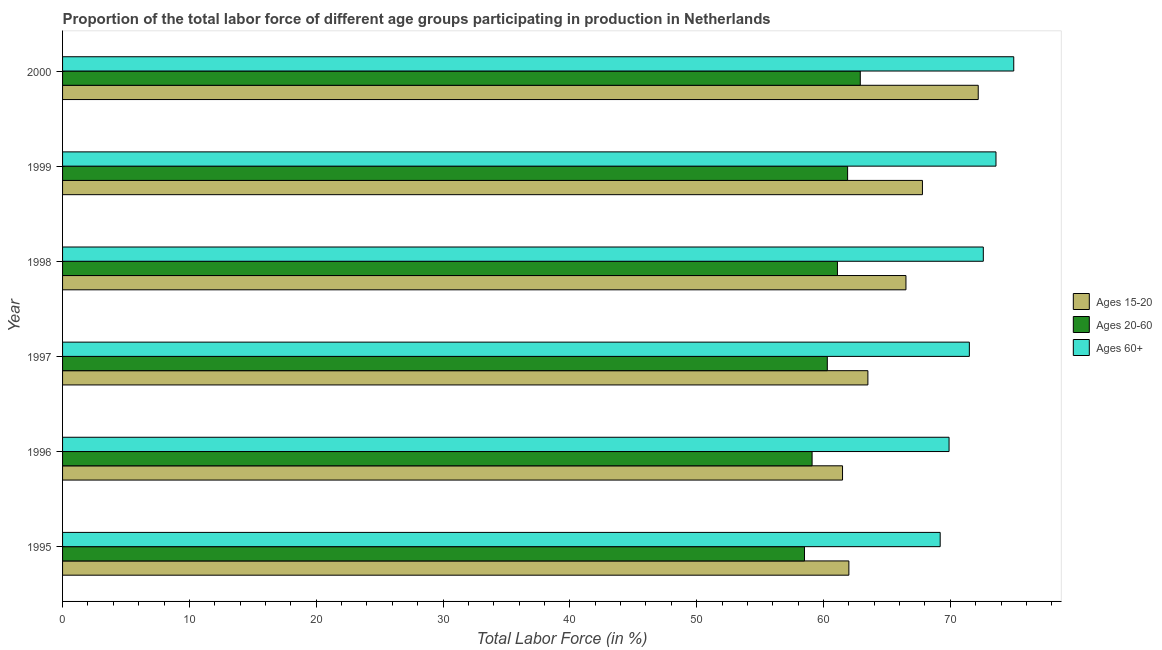How many groups of bars are there?
Make the answer very short. 6. Are the number of bars per tick equal to the number of legend labels?
Offer a very short reply. Yes. How many bars are there on the 6th tick from the bottom?
Ensure brevity in your answer.  3. What is the label of the 4th group of bars from the top?
Give a very brief answer. 1997. In how many cases, is the number of bars for a given year not equal to the number of legend labels?
Provide a succinct answer. 0. What is the percentage of labor force within the age group 20-60 in 1998?
Offer a very short reply. 61.1. Across all years, what is the maximum percentage of labor force within the age group 20-60?
Provide a succinct answer. 62.9. Across all years, what is the minimum percentage of labor force within the age group 15-20?
Ensure brevity in your answer.  61.5. In which year was the percentage of labor force above age 60 maximum?
Offer a terse response. 2000. What is the total percentage of labor force within the age group 15-20 in the graph?
Offer a very short reply. 393.5. What is the difference between the percentage of labor force within the age group 20-60 in 1997 and the percentage of labor force above age 60 in 1996?
Your answer should be very brief. -9.6. What is the average percentage of labor force within the age group 15-20 per year?
Ensure brevity in your answer.  65.58. In how many years, is the percentage of labor force within the age group 15-20 greater than 72 %?
Your answer should be very brief. 1. What is the ratio of the percentage of labor force above age 60 in 1999 to that in 2000?
Make the answer very short. 0.98. Is the percentage of labor force within the age group 20-60 in 1995 less than that in 1999?
Your answer should be compact. Yes. What is the difference between the highest and the lowest percentage of labor force within the age group 20-60?
Your answer should be very brief. 4.4. Is the sum of the percentage of labor force within the age group 20-60 in 1997 and 1999 greater than the maximum percentage of labor force within the age group 15-20 across all years?
Keep it short and to the point. Yes. What does the 3rd bar from the top in 2000 represents?
Offer a very short reply. Ages 15-20. What does the 2nd bar from the bottom in 2000 represents?
Your response must be concise. Ages 20-60. Is it the case that in every year, the sum of the percentage of labor force within the age group 15-20 and percentage of labor force within the age group 20-60 is greater than the percentage of labor force above age 60?
Offer a terse response. Yes. How many bars are there?
Make the answer very short. 18. How many legend labels are there?
Offer a terse response. 3. What is the title of the graph?
Provide a short and direct response. Proportion of the total labor force of different age groups participating in production in Netherlands. Does "Coal" appear as one of the legend labels in the graph?
Keep it short and to the point. No. What is the Total Labor Force (in %) of Ages 20-60 in 1995?
Ensure brevity in your answer.  58.5. What is the Total Labor Force (in %) of Ages 60+ in 1995?
Give a very brief answer. 69.2. What is the Total Labor Force (in %) in Ages 15-20 in 1996?
Offer a very short reply. 61.5. What is the Total Labor Force (in %) in Ages 20-60 in 1996?
Keep it short and to the point. 59.1. What is the Total Labor Force (in %) of Ages 60+ in 1996?
Your answer should be very brief. 69.9. What is the Total Labor Force (in %) of Ages 15-20 in 1997?
Offer a terse response. 63.5. What is the Total Labor Force (in %) in Ages 20-60 in 1997?
Offer a terse response. 60.3. What is the Total Labor Force (in %) of Ages 60+ in 1997?
Offer a very short reply. 71.5. What is the Total Labor Force (in %) of Ages 15-20 in 1998?
Ensure brevity in your answer.  66.5. What is the Total Labor Force (in %) of Ages 20-60 in 1998?
Give a very brief answer. 61.1. What is the Total Labor Force (in %) of Ages 60+ in 1998?
Ensure brevity in your answer.  72.6. What is the Total Labor Force (in %) of Ages 15-20 in 1999?
Offer a terse response. 67.8. What is the Total Labor Force (in %) of Ages 20-60 in 1999?
Keep it short and to the point. 61.9. What is the Total Labor Force (in %) of Ages 60+ in 1999?
Your answer should be compact. 73.6. What is the Total Labor Force (in %) in Ages 15-20 in 2000?
Provide a succinct answer. 72.2. What is the Total Labor Force (in %) of Ages 20-60 in 2000?
Give a very brief answer. 62.9. What is the Total Labor Force (in %) of Ages 60+ in 2000?
Provide a short and direct response. 75. Across all years, what is the maximum Total Labor Force (in %) of Ages 15-20?
Your answer should be very brief. 72.2. Across all years, what is the maximum Total Labor Force (in %) in Ages 20-60?
Provide a succinct answer. 62.9. Across all years, what is the maximum Total Labor Force (in %) of Ages 60+?
Provide a short and direct response. 75. Across all years, what is the minimum Total Labor Force (in %) in Ages 15-20?
Your answer should be very brief. 61.5. Across all years, what is the minimum Total Labor Force (in %) of Ages 20-60?
Your response must be concise. 58.5. Across all years, what is the minimum Total Labor Force (in %) in Ages 60+?
Keep it short and to the point. 69.2. What is the total Total Labor Force (in %) of Ages 15-20 in the graph?
Your answer should be very brief. 393.5. What is the total Total Labor Force (in %) of Ages 20-60 in the graph?
Provide a short and direct response. 363.8. What is the total Total Labor Force (in %) in Ages 60+ in the graph?
Your answer should be very brief. 431.8. What is the difference between the Total Labor Force (in %) in Ages 20-60 in 1995 and that in 1996?
Provide a short and direct response. -0.6. What is the difference between the Total Labor Force (in %) of Ages 15-20 in 1995 and that in 1997?
Provide a short and direct response. -1.5. What is the difference between the Total Labor Force (in %) in Ages 20-60 in 1995 and that in 1997?
Your response must be concise. -1.8. What is the difference between the Total Labor Force (in %) of Ages 20-60 in 1995 and that in 1998?
Keep it short and to the point. -2.6. What is the difference between the Total Labor Force (in %) in Ages 15-20 in 1995 and that in 1999?
Your response must be concise. -5.8. What is the difference between the Total Labor Force (in %) in Ages 20-60 in 1995 and that in 1999?
Keep it short and to the point. -3.4. What is the difference between the Total Labor Force (in %) in Ages 60+ in 1995 and that in 1999?
Provide a succinct answer. -4.4. What is the difference between the Total Labor Force (in %) of Ages 60+ in 1996 and that in 1997?
Keep it short and to the point. -1.6. What is the difference between the Total Labor Force (in %) of Ages 20-60 in 1996 and that in 1998?
Offer a terse response. -2. What is the difference between the Total Labor Force (in %) in Ages 15-20 in 1996 and that in 1999?
Your answer should be compact. -6.3. What is the difference between the Total Labor Force (in %) in Ages 20-60 in 1996 and that in 1999?
Your answer should be very brief. -2.8. What is the difference between the Total Labor Force (in %) of Ages 15-20 in 1996 and that in 2000?
Provide a short and direct response. -10.7. What is the difference between the Total Labor Force (in %) in Ages 15-20 in 1997 and that in 1999?
Ensure brevity in your answer.  -4.3. What is the difference between the Total Labor Force (in %) in Ages 15-20 in 1998 and that in 1999?
Give a very brief answer. -1.3. What is the difference between the Total Labor Force (in %) of Ages 20-60 in 1998 and that in 1999?
Keep it short and to the point. -0.8. What is the difference between the Total Labor Force (in %) in Ages 20-60 in 1998 and that in 2000?
Make the answer very short. -1.8. What is the difference between the Total Labor Force (in %) of Ages 60+ in 1998 and that in 2000?
Your answer should be compact. -2.4. What is the difference between the Total Labor Force (in %) of Ages 20-60 in 1995 and the Total Labor Force (in %) of Ages 60+ in 1996?
Offer a very short reply. -11.4. What is the difference between the Total Labor Force (in %) in Ages 15-20 in 1995 and the Total Labor Force (in %) in Ages 20-60 in 1997?
Offer a terse response. 1.7. What is the difference between the Total Labor Force (in %) of Ages 15-20 in 1995 and the Total Labor Force (in %) of Ages 60+ in 1997?
Offer a very short reply. -9.5. What is the difference between the Total Labor Force (in %) in Ages 20-60 in 1995 and the Total Labor Force (in %) in Ages 60+ in 1997?
Keep it short and to the point. -13. What is the difference between the Total Labor Force (in %) in Ages 15-20 in 1995 and the Total Labor Force (in %) in Ages 60+ in 1998?
Make the answer very short. -10.6. What is the difference between the Total Labor Force (in %) of Ages 20-60 in 1995 and the Total Labor Force (in %) of Ages 60+ in 1998?
Offer a terse response. -14.1. What is the difference between the Total Labor Force (in %) of Ages 15-20 in 1995 and the Total Labor Force (in %) of Ages 60+ in 1999?
Provide a succinct answer. -11.6. What is the difference between the Total Labor Force (in %) of Ages 20-60 in 1995 and the Total Labor Force (in %) of Ages 60+ in 1999?
Provide a succinct answer. -15.1. What is the difference between the Total Labor Force (in %) in Ages 20-60 in 1995 and the Total Labor Force (in %) in Ages 60+ in 2000?
Provide a short and direct response. -16.5. What is the difference between the Total Labor Force (in %) in Ages 15-20 in 1996 and the Total Labor Force (in %) in Ages 20-60 in 1997?
Your answer should be very brief. 1.2. What is the difference between the Total Labor Force (in %) in Ages 15-20 in 1996 and the Total Labor Force (in %) in Ages 20-60 in 1998?
Keep it short and to the point. 0.4. What is the difference between the Total Labor Force (in %) in Ages 15-20 in 1996 and the Total Labor Force (in %) in Ages 60+ in 1998?
Give a very brief answer. -11.1. What is the difference between the Total Labor Force (in %) of Ages 15-20 in 1996 and the Total Labor Force (in %) of Ages 60+ in 1999?
Ensure brevity in your answer.  -12.1. What is the difference between the Total Labor Force (in %) in Ages 15-20 in 1996 and the Total Labor Force (in %) in Ages 20-60 in 2000?
Provide a succinct answer. -1.4. What is the difference between the Total Labor Force (in %) in Ages 20-60 in 1996 and the Total Labor Force (in %) in Ages 60+ in 2000?
Provide a succinct answer. -15.9. What is the difference between the Total Labor Force (in %) of Ages 15-20 in 1997 and the Total Labor Force (in %) of Ages 20-60 in 1998?
Ensure brevity in your answer.  2.4. What is the difference between the Total Labor Force (in %) of Ages 15-20 in 1997 and the Total Labor Force (in %) of Ages 60+ in 1999?
Ensure brevity in your answer.  -10.1. What is the difference between the Total Labor Force (in %) of Ages 20-60 in 1997 and the Total Labor Force (in %) of Ages 60+ in 2000?
Offer a terse response. -14.7. What is the difference between the Total Labor Force (in %) in Ages 15-20 in 1998 and the Total Labor Force (in %) in Ages 20-60 in 1999?
Offer a very short reply. 4.6. What is the difference between the Total Labor Force (in %) in Ages 15-20 in 1998 and the Total Labor Force (in %) in Ages 60+ in 1999?
Offer a terse response. -7.1. What is the difference between the Total Labor Force (in %) of Ages 15-20 in 1998 and the Total Labor Force (in %) of Ages 20-60 in 2000?
Keep it short and to the point. 3.6. What is the difference between the Total Labor Force (in %) in Ages 15-20 in 1998 and the Total Labor Force (in %) in Ages 60+ in 2000?
Provide a succinct answer. -8.5. What is the difference between the Total Labor Force (in %) in Ages 20-60 in 1998 and the Total Labor Force (in %) in Ages 60+ in 2000?
Your response must be concise. -13.9. What is the difference between the Total Labor Force (in %) of Ages 20-60 in 1999 and the Total Labor Force (in %) of Ages 60+ in 2000?
Offer a terse response. -13.1. What is the average Total Labor Force (in %) of Ages 15-20 per year?
Your answer should be compact. 65.58. What is the average Total Labor Force (in %) of Ages 20-60 per year?
Give a very brief answer. 60.63. What is the average Total Labor Force (in %) in Ages 60+ per year?
Make the answer very short. 71.97. In the year 1995, what is the difference between the Total Labor Force (in %) of Ages 15-20 and Total Labor Force (in %) of Ages 20-60?
Make the answer very short. 3.5. In the year 1995, what is the difference between the Total Labor Force (in %) of Ages 20-60 and Total Labor Force (in %) of Ages 60+?
Ensure brevity in your answer.  -10.7. In the year 1996, what is the difference between the Total Labor Force (in %) of Ages 15-20 and Total Labor Force (in %) of Ages 60+?
Keep it short and to the point. -8.4. In the year 1997, what is the difference between the Total Labor Force (in %) of Ages 15-20 and Total Labor Force (in %) of Ages 20-60?
Ensure brevity in your answer.  3.2. In the year 1997, what is the difference between the Total Labor Force (in %) in Ages 15-20 and Total Labor Force (in %) in Ages 60+?
Keep it short and to the point. -8. In the year 1998, what is the difference between the Total Labor Force (in %) of Ages 15-20 and Total Labor Force (in %) of Ages 60+?
Offer a very short reply. -6.1. In the year 1998, what is the difference between the Total Labor Force (in %) of Ages 20-60 and Total Labor Force (in %) of Ages 60+?
Provide a succinct answer. -11.5. In the year 1999, what is the difference between the Total Labor Force (in %) of Ages 15-20 and Total Labor Force (in %) of Ages 20-60?
Keep it short and to the point. 5.9. In the year 2000, what is the difference between the Total Labor Force (in %) of Ages 15-20 and Total Labor Force (in %) of Ages 60+?
Keep it short and to the point. -2.8. What is the ratio of the Total Labor Force (in %) in Ages 20-60 in 1995 to that in 1996?
Keep it short and to the point. 0.99. What is the ratio of the Total Labor Force (in %) of Ages 15-20 in 1995 to that in 1997?
Ensure brevity in your answer.  0.98. What is the ratio of the Total Labor Force (in %) in Ages 20-60 in 1995 to that in 1997?
Ensure brevity in your answer.  0.97. What is the ratio of the Total Labor Force (in %) of Ages 60+ in 1995 to that in 1997?
Give a very brief answer. 0.97. What is the ratio of the Total Labor Force (in %) in Ages 15-20 in 1995 to that in 1998?
Offer a terse response. 0.93. What is the ratio of the Total Labor Force (in %) of Ages 20-60 in 1995 to that in 1998?
Give a very brief answer. 0.96. What is the ratio of the Total Labor Force (in %) of Ages 60+ in 1995 to that in 1998?
Your answer should be very brief. 0.95. What is the ratio of the Total Labor Force (in %) of Ages 15-20 in 1995 to that in 1999?
Your response must be concise. 0.91. What is the ratio of the Total Labor Force (in %) in Ages 20-60 in 1995 to that in 1999?
Your answer should be compact. 0.95. What is the ratio of the Total Labor Force (in %) in Ages 60+ in 1995 to that in 1999?
Make the answer very short. 0.94. What is the ratio of the Total Labor Force (in %) in Ages 15-20 in 1995 to that in 2000?
Give a very brief answer. 0.86. What is the ratio of the Total Labor Force (in %) of Ages 60+ in 1995 to that in 2000?
Provide a short and direct response. 0.92. What is the ratio of the Total Labor Force (in %) of Ages 15-20 in 1996 to that in 1997?
Your answer should be very brief. 0.97. What is the ratio of the Total Labor Force (in %) of Ages 20-60 in 1996 to that in 1997?
Provide a short and direct response. 0.98. What is the ratio of the Total Labor Force (in %) of Ages 60+ in 1996 to that in 1997?
Make the answer very short. 0.98. What is the ratio of the Total Labor Force (in %) of Ages 15-20 in 1996 to that in 1998?
Your response must be concise. 0.92. What is the ratio of the Total Labor Force (in %) of Ages 20-60 in 1996 to that in 1998?
Your answer should be very brief. 0.97. What is the ratio of the Total Labor Force (in %) in Ages 60+ in 1996 to that in 1998?
Offer a very short reply. 0.96. What is the ratio of the Total Labor Force (in %) in Ages 15-20 in 1996 to that in 1999?
Ensure brevity in your answer.  0.91. What is the ratio of the Total Labor Force (in %) of Ages 20-60 in 1996 to that in 1999?
Provide a succinct answer. 0.95. What is the ratio of the Total Labor Force (in %) of Ages 60+ in 1996 to that in 1999?
Your answer should be very brief. 0.95. What is the ratio of the Total Labor Force (in %) of Ages 15-20 in 1996 to that in 2000?
Keep it short and to the point. 0.85. What is the ratio of the Total Labor Force (in %) in Ages 20-60 in 1996 to that in 2000?
Give a very brief answer. 0.94. What is the ratio of the Total Labor Force (in %) of Ages 60+ in 1996 to that in 2000?
Give a very brief answer. 0.93. What is the ratio of the Total Labor Force (in %) in Ages 15-20 in 1997 to that in 1998?
Offer a very short reply. 0.95. What is the ratio of the Total Labor Force (in %) of Ages 20-60 in 1997 to that in 1998?
Give a very brief answer. 0.99. What is the ratio of the Total Labor Force (in %) in Ages 15-20 in 1997 to that in 1999?
Give a very brief answer. 0.94. What is the ratio of the Total Labor Force (in %) in Ages 20-60 in 1997 to that in 1999?
Give a very brief answer. 0.97. What is the ratio of the Total Labor Force (in %) in Ages 60+ in 1997 to that in 1999?
Make the answer very short. 0.97. What is the ratio of the Total Labor Force (in %) in Ages 15-20 in 1997 to that in 2000?
Provide a short and direct response. 0.88. What is the ratio of the Total Labor Force (in %) in Ages 20-60 in 1997 to that in 2000?
Offer a terse response. 0.96. What is the ratio of the Total Labor Force (in %) in Ages 60+ in 1997 to that in 2000?
Give a very brief answer. 0.95. What is the ratio of the Total Labor Force (in %) in Ages 15-20 in 1998 to that in 1999?
Make the answer very short. 0.98. What is the ratio of the Total Labor Force (in %) of Ages 20-60 in 1998 to that in 1999?
Ensure brevity in your answer.  0.99. What is the ratio of the Total Labor Force (in %) in Ages 60+ in 1998 to that in 1999?
Offer a terse response. 0.99. What is the ratio of the Total Labor Force (in %) of Ages 15-20 in 1998 to that in 2000?
Your answer should be very brief. 0.92. What is the ratio of the Total Labor Force (in %) in Ages 20-60 in 1998 to that in 2000?
Keep it short and to the point. 0.97. What is the ratio of the Total Labor Force (in %) in Ages 60+ in 1998 to that in 2000?
Make the answer very short. 0.97. What is the ratio of the Total Labor Force (in %) of Ages 15-20 in 1999 to that in 2000?
Make the answer very short. 0.94. What is the ratio of the Total Labor Force (in %) in Ages 20-60 in 1999 to that in 2000?
Provide a short and direct response. 0.98. What is the ratio of the Total Labor Force (in %) in Ages 60+ in 1999 to that in 2000?
Keep it short and to the point. 0.98. What is the difference between the highest and the second highest Total Labor Force (in %) of Ages 20-60?
Offer a very short reply. 1. What is the difference between the highest and the lowest Total Labor Force (in %) in Ages 60+?
Your response must be concise. 5.8. 